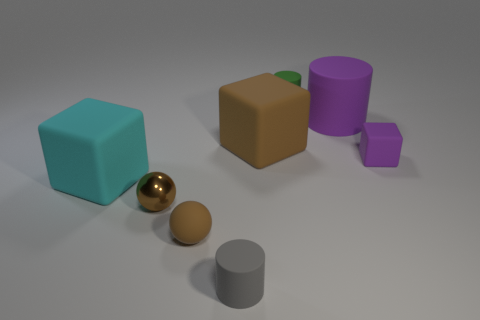Add 1 large cyan matte cubes. How many objects exist? 9 Subtract all spheres. How many objects are left? 6 Subtract all tiny brown metallic balls. Subtract all large objects. How many objects are left? 4 Add 7 brown blocks. How many brown blocks are left? 8 Add 7 large purple spheres. How many large purple spheres exist? 7 Subtract 1 brown blocks. How many objects are left? 7 